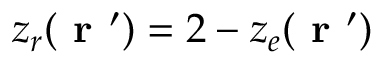Convert formula to latex. <formula><loc_0><loc_0><loc_500><loc_500>z _ { r } ( r ^ { \prime } ) = 2 - z _ { e } ( r ^ { \prime } )</formula> 